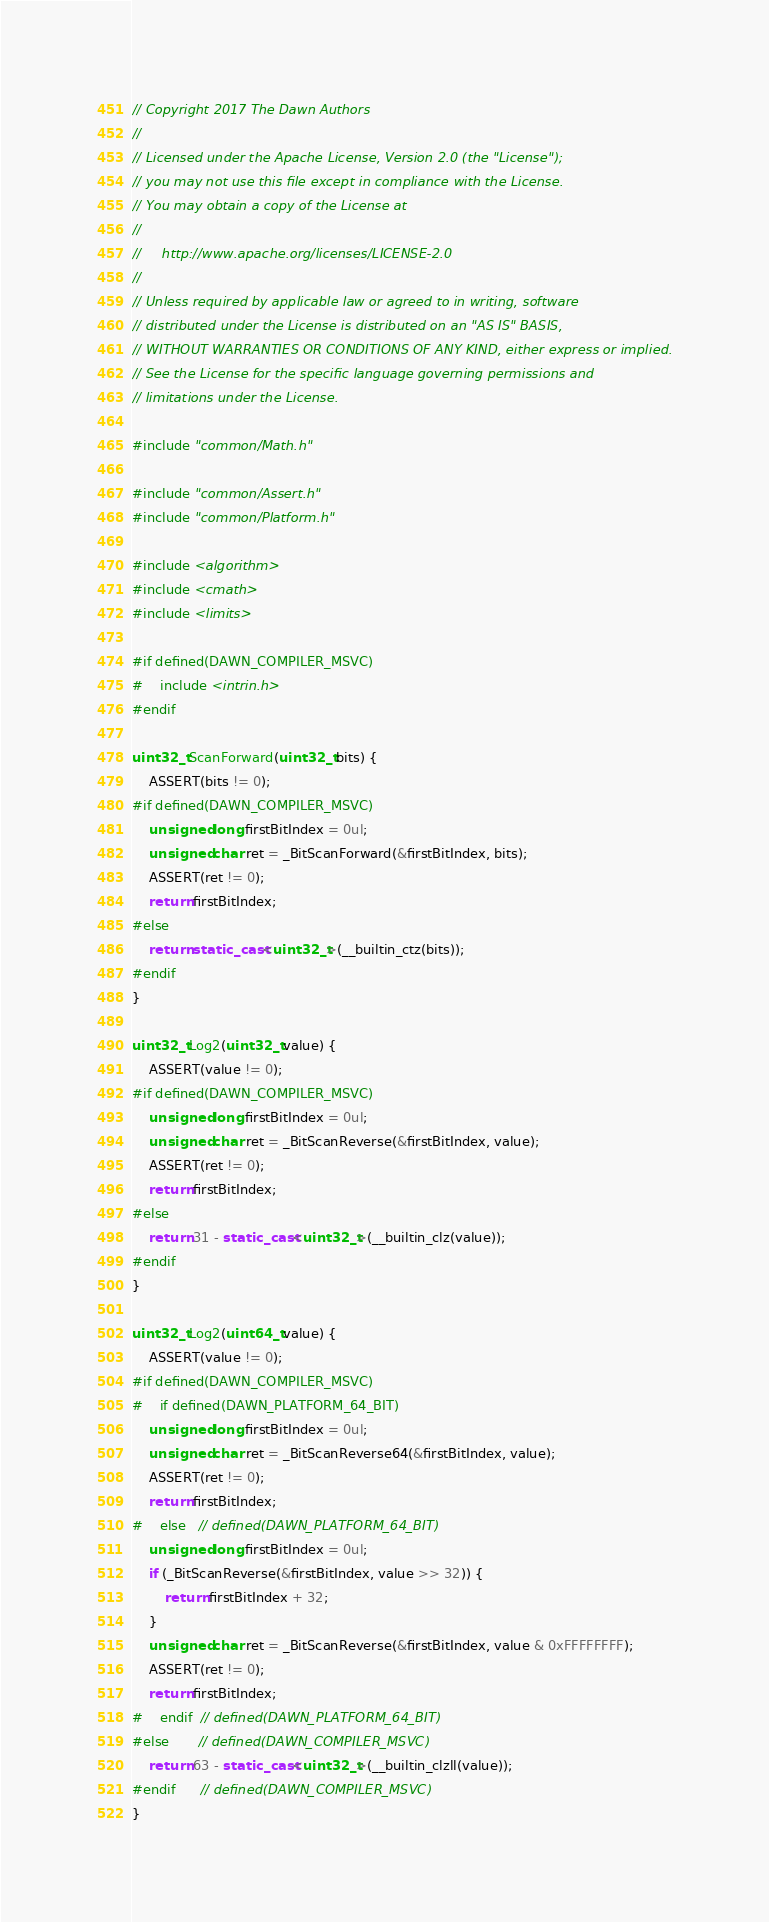Convert code to text. <code><loc_0><loc_0><loc_500><loc_500><_C++_>// Copyright 2017 The Dawn Authors
//
// Licensed under the Apache License, Version 2.0 (the "License");
// you may not use this file except in compliance with the License.
// You may obtain a copy of the License at
//
//     http://www.apache.org/licenses/LICENSE-2.0
//
// Unless required by applicable law or agreed to in writing, software
// distributed under the License is distributed on an "AS IS" BASIS,
// WITHOUT WARRANTIES OR CONDITIONS OF ANY KIND, either express or implied.
// See the License for the specific language governing permissions and
// limitations under the License.

#include "common/Math.h"

#include "common/Assert.h"
#include "common/Platform.h"

#include <algorithm>
#include <cmath>
#include <limits>

#if defined(DAWN_COMPILER_MSVC)
#    include <intrin.h>
#endif

uint32_t ScanForward(uint32_t bits) {
    ASSERT(bits != 0);
#if defined(DAWN_COMPILER_MSVC)
    unsigned long firstBitIndex = 0ul;
    unsigned char ret = _BitScanForward(&firstBitIndex, bits);
    ASSERT(ret != 0);
    return firstBitIndex;
#else
    return static_cast<uint32_t>(__builtin_ctz(bits));
#endif
}

uint32_t Log2(uint32_t value) {
    ASSERT(value != 0);
#if defined(DAWN_COMPILER_MSVC)
    unsigned long firstBitIndex = 0ul;
    unsigned char ret = _BitScanReverse(&firstBitIndex, value);
    ASSERT(ret != 0);
    return firstBitIndex;
#else
    return 31 - static_cast<uint32_t>(__builtin_clz(value));
#endif
}

uint32_t Log2(uint64_t value) {
    ASSERT(value != 0);
#if defined(DAWN_COMPILER_MSVC)
#    if defined(DAWN_PLATFORM_64_BIT)
    unsigned long firstBitIndex = 0ul;
    unsigned char ret = _BitScanReverse64(&firstBitIndex, value);
    ASSERT(ret != 0);
    return firstBitIndex;
#    else   // defined(DAWN_PLATFORM_64_BIT)
    unsigned long firstBitIndex = 0ul;
    if (_BitScanReverse(&firstBitIndex, value >> 32)) {
        return firstBitIndex + 32;
    }
    unsigned char ret = _BitScanReverse(&firstBitIndex, value & 0xFFFFFFFF);
    ASSERT(ret != 0);
    return firstBitIndex;
#    endif  // defined(DAWN_PLATFORM_64_BIT)
#else       // defined(DAWN_COMPILER_MSVC)
    return 63 - static_cast<uint32_t>(__builtin_clzll(value));
#endif      // defined(DAWN_COMPILER_MSVC)
}
</code> 